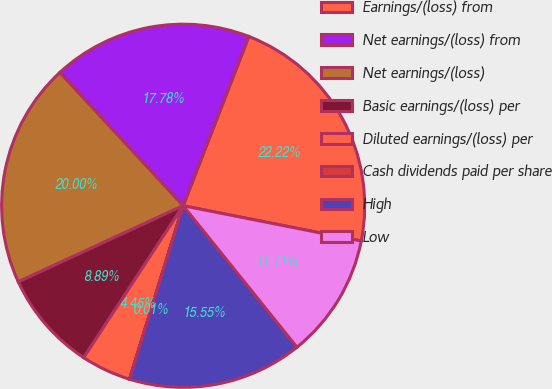<chart> <loc_0><loc_0><loc_500><loc_500><pie_chart><fcel>Earnings/(loss) from<fcel>Net earnings/(loss) from<fcel>Net earnings/(loss)<fcel>Basic earnings/(loss) per<fcel>Diluted earnings/(loss) per<fcel>Cash dividends paid per share<fcel>High<fcel>Low<nl><fcel>22.22%<fcel>17.78%<fcel>20.0%<fcel>8.89%<fcel>4.45%<fcel>0.01%<fcel>15.55%<fcel>11.11%<nl></chart> 